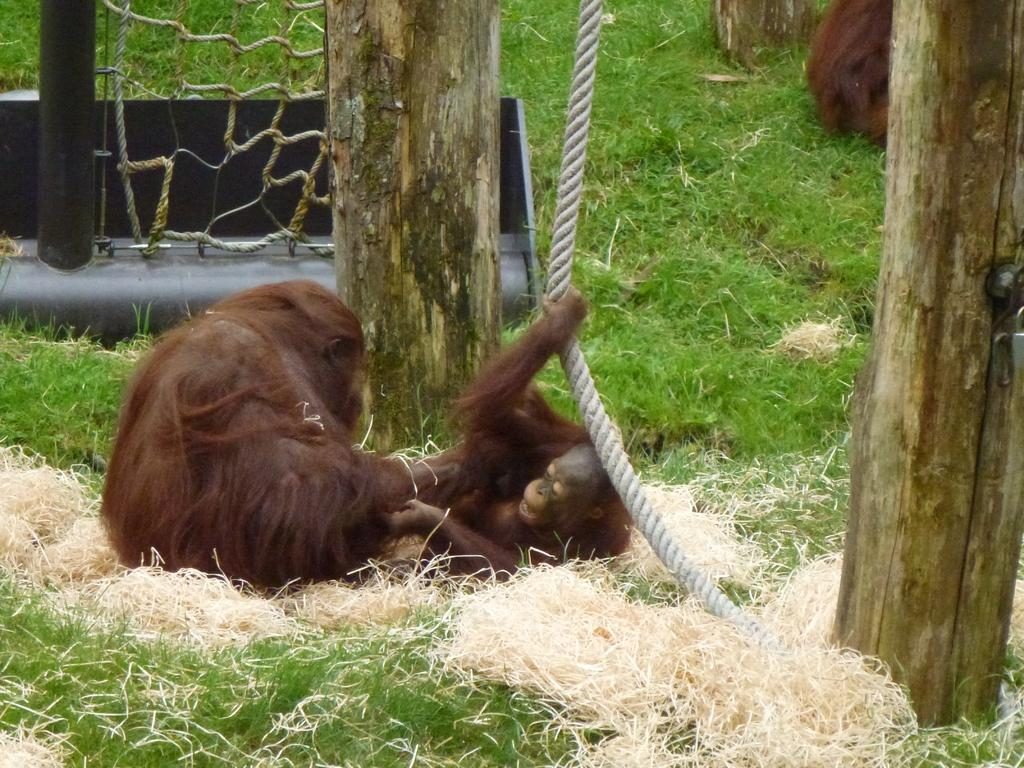What type of animals are in the image? There are orangutans in the image. What is on the ground in the image? There is grass on the ground in the image. What object can be seen in the image that is used for climbing or swinging? There is a rope in the image. What is in the background of the image that resembles a net made of ropes? There is a rope net in the background of the image. What type of vegetation is visible in the image? Tree trunks are visible in the image. What type of sign can be seen in the image? There is no sign present in the image. How many deer are visible in the image? There are no deer present in the image. 